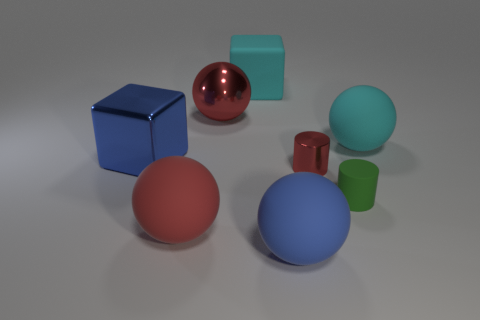Subtract all blue balls. How many balls are left? 3 Add 1 blue shiny things. How many objects exist? 9 Subtract all blue balls. How many balls are left? 3 Subtract all cylinders. How many objects are left? 6 Subtract 1 cylinders. How many cylinders are left? 1 Add 6 large cyan rubber blocks. How many large cyan rubber blocks are left? 7 Add 6 rubber blocks. How many rubber blocks exist? 7 Subtract 0 brown cylinders. How many objects are left? 8 Subtract all green blocks. Subtract all purple cylinders. How many blocks are left? 2 Subtract all yellow spheres. How many green cylinders are left? 1 